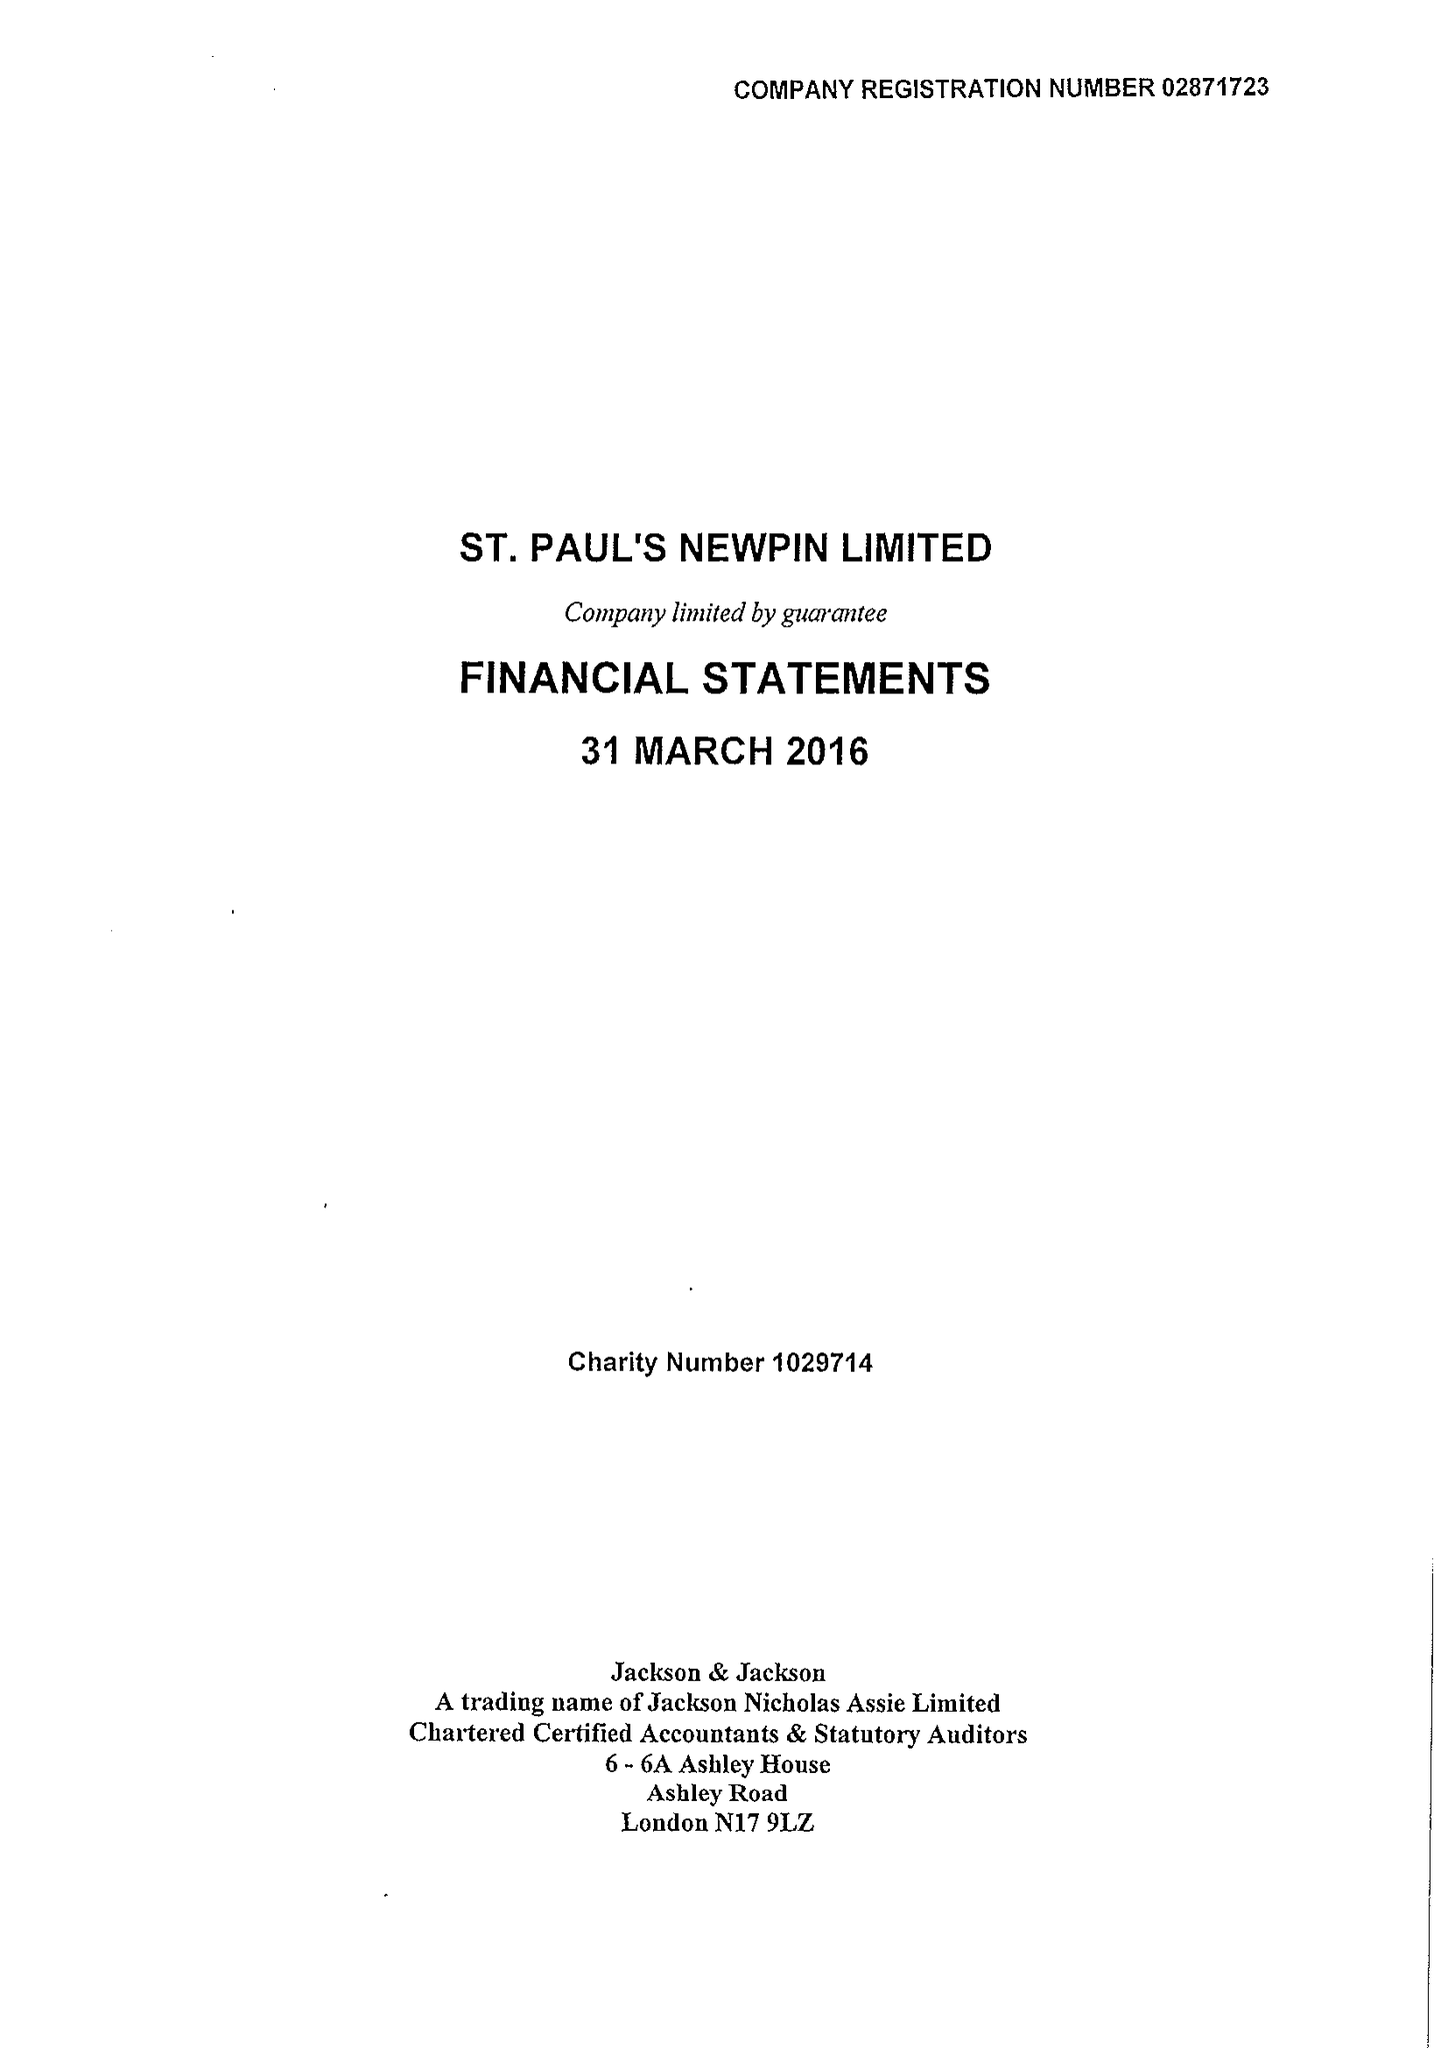What is the value for the spending_annually_in_british_pounds?
Answer the question using a single word or phrase. 105434.00 